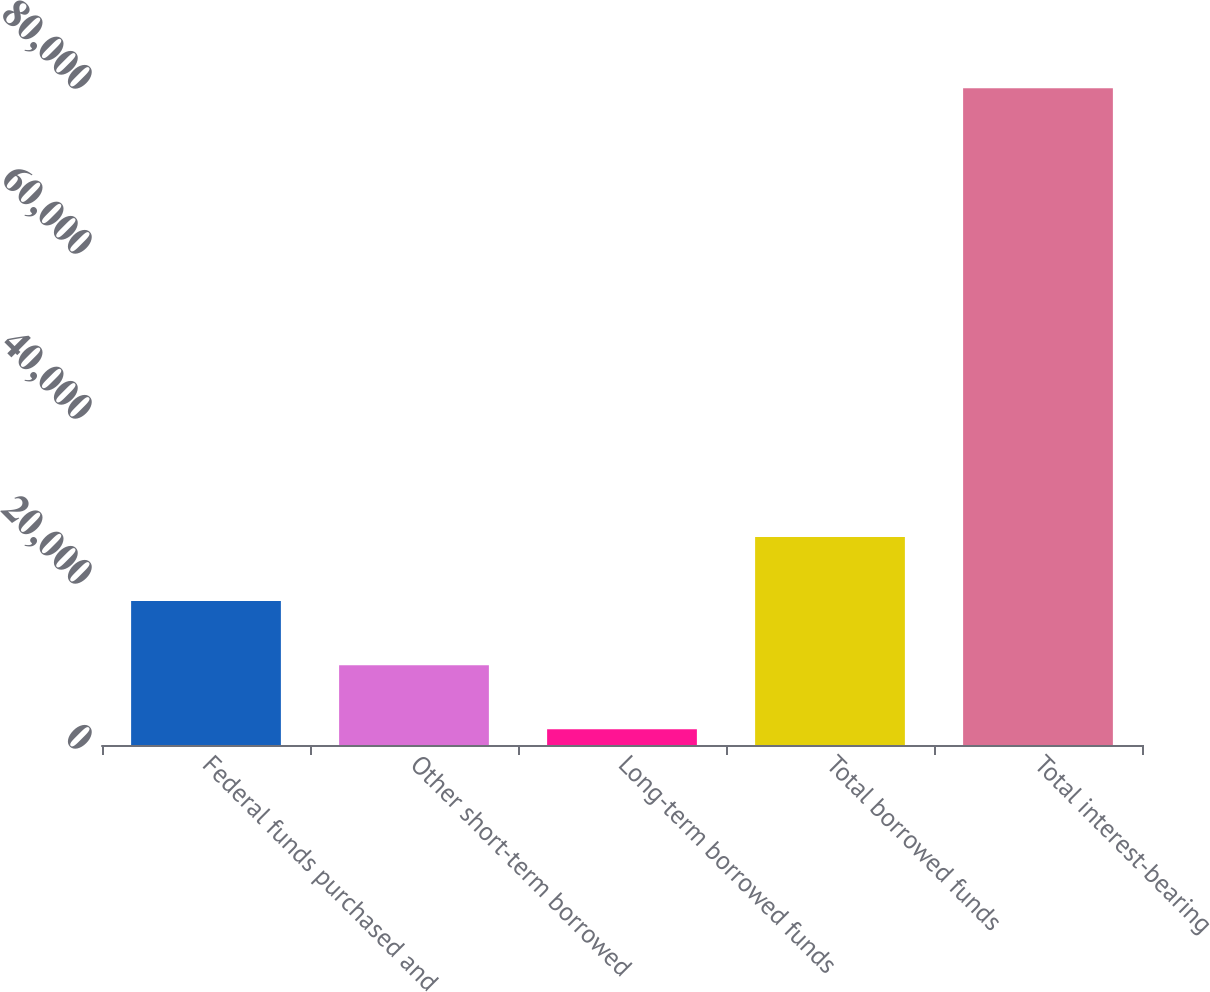Convert chart to OTSL. <chart><loc_0><loc_0><loc_500><loc_500><bar_chart><fcel>Federal funds purchased and<fcel>Other short-term borrowed<fcel>Long-term borrowed funds<fcel>Total borrowed funds<fcel>Total interest-bearing<nl><fcel>17447.4<fcel>9677.2<fcel>1907<fcel>25217.6<fcel>79609<nl></chart> 